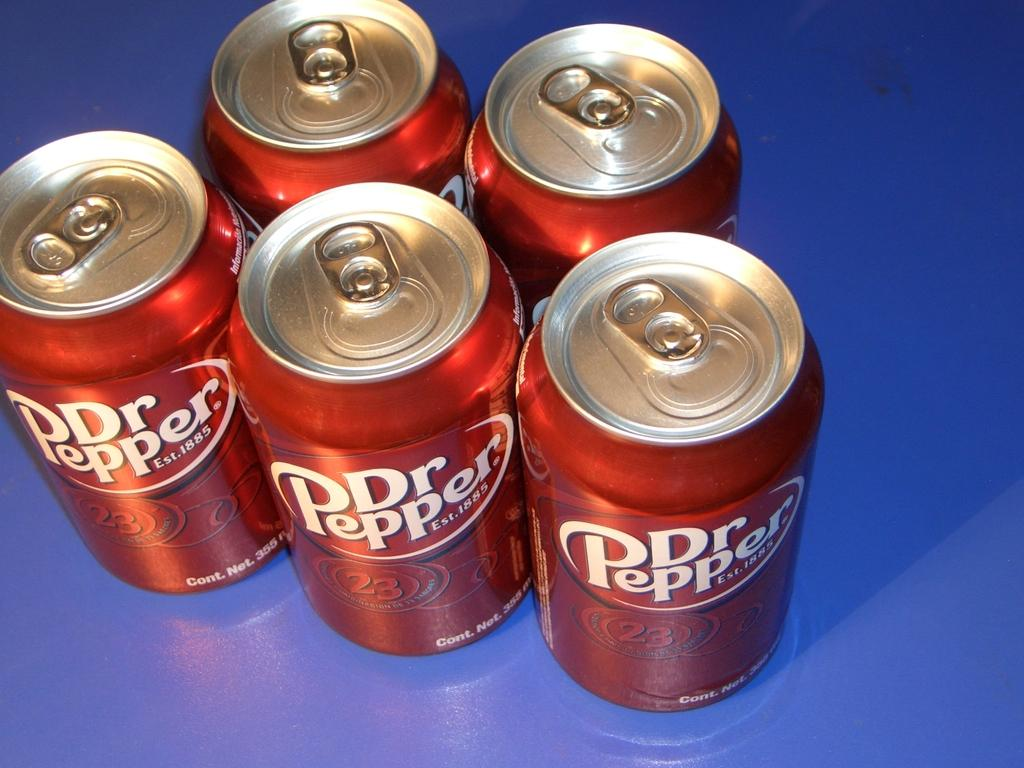<image>
Summarize the visual content of the image. five cans unopened of dr pepper on a blue surface 